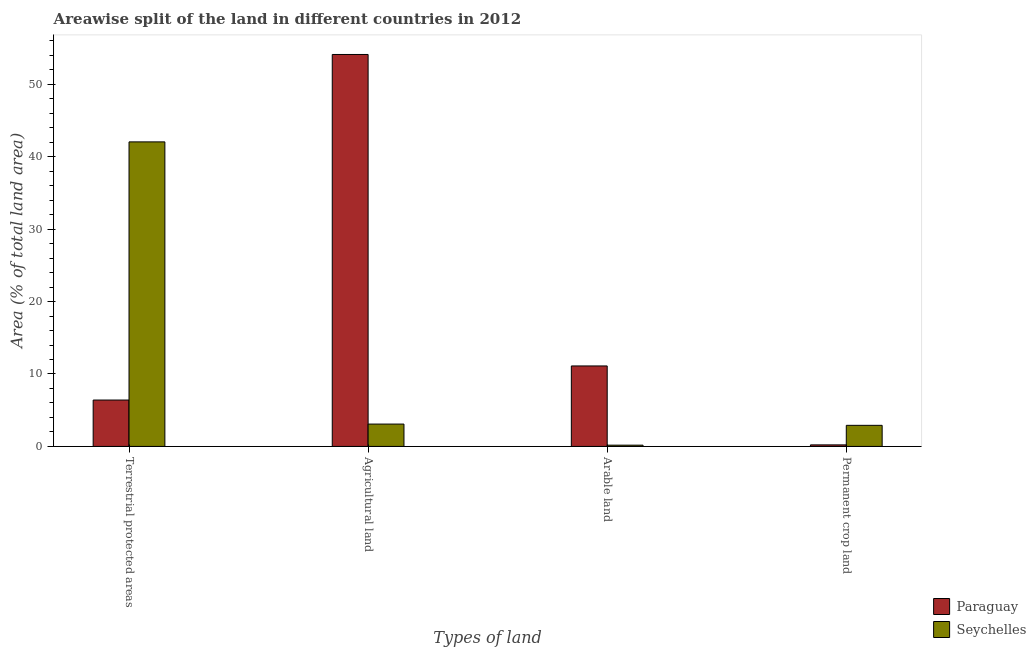How many different coloured bars are there?
Ensure brevity in your answer.  2. Are the number of bars on each tick of the X-axis equal?
Give a very brief answer. Yes. How many bars are there on the 1st tick from the right?
Your answer should be very brief. 2. What is the label of the 2nd group of bars from the left?
Your answer should be compact. Agricultural land. What is the percentage of area under arable land in Seychelles?
Your answer should be compact. 0.17. Across all countries, what is the maximum percentage of area under arable land?
Offer a terse response. 11.11. Across all countries, what is the minimum percentage of area under arable land?
Make the answer very short. 0.17. In which country was the percentage of area under arable land maximum?
Provide a short and direct response. Paraguay. In which country was the percentage of area under arable land minimum?
Give a very brief answer. Seychelles. What is the total percentage of area under agricultural land in the graph?
Provide a short and direct response. 57.2. What is the difference between the percentage of area under permanent crop land in Paraguay and that in Seychelles?
Keep it short and to the point. -2.7. What is the difference between the percentage of area under agricultural land in Seychelles and the percentage of land under terrestrial protection in Paraguay?
Make the answer very short. -3.32. What is the average percentage of area under permanent crop land per country?
Ensure brevity in your answer.  1.56. What is the difference between the percentage of area under permanent crop land and percentage of land under terrestrial protection in Seychelles?
Ensure brevity in your answer.  -39.13. What is the ratio of the percentage of area under arable land in Seychelles to that in Paraguay?
Provide a succinct answer. 0.02. Is the percentage of area under permanent crop land in Seychelles less than that in Paraguay?
Give a very brief answer. No. What is the difference between the highest and the second highest percentage of area under permanent crop land?
Your answer should be very brief. 2.7. What is the difference between the highest and the lowest percentage of area under arable land?
Offer a very short reply. 10.94. In how many countries, is the percentage of area under agricultural land greater than the average percentage of area under agricultural land taken over all countries?
Offer a terse response. 1. Is the sum of the percentage of area under agricultural land in Seychelles and Paraguay greater than the maximum percentage of area under arable land across all countries?
Your answer should be compact. Yes. What does the 2nd bar from the left in Terrestrial protected areas represents?
Offer a terse response. Seychelles. What does the 2nd bar from the right in Permanent crop land represents?
Ensure brevity in your answer.  Paraguay. Is it the case that in every country, the sum of the percentage of land under terrestrial protection and percentage of area under agricultural land is greater than the percentage of area under arable land?
Provide a succinct answer. Yes. Are all the bars in the graph horizontal?
Your answer should be very brief. No. How many countries are there in the graph?
Make the answer very short. 2. Are the values on the major ticks of Y-axis written in scientific E-notation?
Ensure brevity in your answer.  No. Does the graph contain any zero values?
Ensure brevity in your answer.  No. Does the graph contain grids?
Make the answer very short. No. How many legend labels are there?
Ensure brevity in your answer.  2. What is the title of the graph?
Your answer should be very brief. Areawise split of the land in different countries in 2012. What is the label or title of the X-axis?
Offer a terse response. Types of land. What is the label or title of the Y-axis?
Make the answer very short. Area (% of total land area). What is the Area (% of total land area) in Paraguay in Terrestrial protected areas?
Provide a succinct answer. 6.4. What is the Area (% of total land area) in Seychelles in Terrestrial protected areas?
Make the answer very short. 42.05. What is the Area (% of total land area) of Paraguay in Agricultural land?
Provide a succinct answer. 54.12. What is the Area (% of total land area) in Seychelles in Agricultural land?
Your response must be concise. 3.09. What is the Area (% of total land area) of Paraguay in Arable land?
Your response must be concise. 11.11. What is the Area (% of total land area) of Seychelles in Arable land?
Provide a succinct answer. 0.17. What is the Area (% of total land area) of Paraguay in Permanent crop land?
Provide a short and direct response. 0.21. What is the Area (% of total land area) in Seychelles in Permanent crop land?
Ensure brevity in your answer.  2.91. Across all Types of land, what is the maximum Area (% of total land area) of Paraguay?
Your answer should be compact. 54.12. Across all Types of land, what is the maximum Area (% of total land area) in Seychelles?
Your answer should be very brief. 42.05. Across all Types of land, what is the minimum Area (% of total land area) in Paraguay?
Your response must be concise. 0.21. Across all Types of land, what is the minimum Area (% of total land area) in Seychelles?
Offer a terse response. 0.17. What is the total Area (% of total land area) of Paraguay in the graph?
Your answer should be compact. 71.85. What is the total Area (% of total land area) in Seychelles in the graph?
Your response must be concise. 48.22. What is the difference between the Area (% of total land area) of Paraguay in Terrestrial protected areas and that in Agricultural land?
Keep it short and to the point. -47.71. What is the difference between the Area (% of total land area) of Seychelles in Terrestrial protected areas and that in Agricultural land?
Offer a terse response. 38.96. What is the difference between the Area (% of total land area) of Paraguay in Terrestrial protected areas and that in Arable land?
Your response must be concise. -4.71. What is the difference between the Area (% of total land area) in Seychelles in Terrestrial protected areas and that in Arable land?
Keep it short and to the point. 41.87. What is the difference between the Area (% of total land area) of Paraguay in Terrestrial protected areas and that in Permanent crop land?
Provide a succinct answer. 6.19. What is the difference between the Area (% of total land area) of Seychelles in Terrestrial protected areas and that in Permanent crop land?
Make the answer very short. 39.13. What is the difference between the Area (% of total land area) in Paraguay in Agricultural land and that in Arable land?
Make the answer very short. 43. What is the difference between the Area (% of total land area) in Seychelles in Agricultural land and that in Arable land?
Your answer should be very brief. 2.91. What is the difference between the Area (% of total land area) in Paraguay in Agricultural land and that in Permanent crop land?
Give a very brief answer. 53.9. What is the difference between the Area (% of total land area) in Seychelles in Agricultural land and that in Permanent crop land?
Offer a terse response. 0.17. What is the difference between the Area (% of total land area) in Paraguay in Arable land and that in Permanent crop land?
Provide a short and direct response. 10.9. What is the difference between the Area (% of total land area) of Seychelles in Arable land and that in Permanent crop land?
Make the answer very short. -2.74. What is the difference between the Area (% of total land area) in Paraguay in Terrestrial protected areas and the Area (% of total land area) in Seychelles in Agricultural land?
Offer a terse response. 3.32. What is the difference between the Area (% of total land area) of Paraguay in Terrestrial protected areas and the Area (% of total land area) of Seychelles in Arable land?
Provide a short and direct response. 6.23. What is the difference between the Area (% of total land area) of Paraguay in Terrestrial protected areas and the Area (% of total land area) of Seychelles in Permanent crop land?
Offer a very short reply. 3.49. What is the difference between the Area (% of total land area) in Paraguay in Agricultural land and the Area (% of total land area) in Seychelles in Arable land?
Give a very brief answer. 53.94. What is the difference between the Area (% of total land area) of Paraguay in Agricultural land and the Area (% of total land area) of Seychelles in Permanent crop land?
Your response must be concise. 51.2. What is the difference between the Area (% of total land area) in Paraguay in Arable land and the Area (% of total land area) in Seychelles in Permanent crop land?
Provide a short and direct response. 8.2. What is the average Area (% of total land area) of Paraguay per Types of land?
Keep it short and to the point. 17.96. What is the average Area (% of total land area) in Seychelles per Types of land?
Offer a terse response. 12.06. What is the difference between the Area (% of total land area) of Paraguay and Area (% of total land area) of Seychelles in Terrestrial protected areas?
Give a very brief answer. -35.64. What is the difference between the Area (% of total land area) in Paraguay and Area (% of total land area) in Seychelles in Agricultural land?
Your answer should be compact. 51.03. What is the difference between the Area (% of total land area) in Paraguay and Area (% of total land area) in Seychelles in Arable land?
Offer a terse response. 10.94. What is the difference between the Area (% of total land area) in Paraguay and Area (% of total land area) in Seychelles in Permanent crop land?
Offer a terse response. -2.7. What is the ratio of the Area (% of total land area) in Paraguay in Terrestrial protected areas to that in Agricultural land?
Your answer should be compact. 0.12. What is the ratio of the Area (% of total land area) of Seychelles in Terrestrial protected areas to that in Agricultural land?
Offer a very short reply. 13.62. What is the ratio of the Area (% of total land area) of Paraguay in Terrestrial protected areas to that in Arable land?
Provide a short and direct response. 0.58. What is the ratio of the Area (% of total land area) of Seychelles in Terrestrial protected areas to that in Arable land?
Offer a terse response. 241.77. What is the ratio of the Area (% of total land area) in Paraguay in Terrestrial protected areas to that in Permanent crop land?
Your response must be concise. 29.93. What is the ratio of the Area (% of total land area) in Seychelles in Terrestrial protected areas to that in Permanent crop land?
Offer a terse response. 14.43. What is the ratio of the Area (% of total land area) in Paraguay in Agricultural land to that in Arable land?
Offer a terse response. 4.87. What is the ratio of the Area (% of total land area) in Seychelles in Agricultural land to that in Arable land?
Keep it short and to the point. 17.75. What is the ratio of the Area (% of total land area) of Paraguay in Agricultural land to that in Permanent crop land?
Make the answer very short. 252.94. What is the ratio of the Area (% of total land area) in Seychelles in Agricultural land to that in Permanent crop land?
Provide a short and direct response. 1.06. What is the ratio of the Area (% of total land area) in Paraguay in Arable land to that in Permanent crop land?
Provide a short and direct response. 51.94. What is the ratio of the Area (% of total land area) of Seychelles in Arable land to that in Permanent crop land?
Give a very brief answer. 0.06. What is the difference between the highest and the second highest Area (% of total land area) of Paraguay?
Offer a very short reply. 43. What is the difference between the highest and the second highest Area (% of total land area) of Seychelles?
Provide a short and direct response. 38.96. What is the difference between the highest and the lowest Area (% of total land area) in Paraguay?
Your response must be concise. 53.9. What is the difference between the highest and the lowest Area (% of total land area) of Seychelles?
Provide a short and direct response. 41.87. 